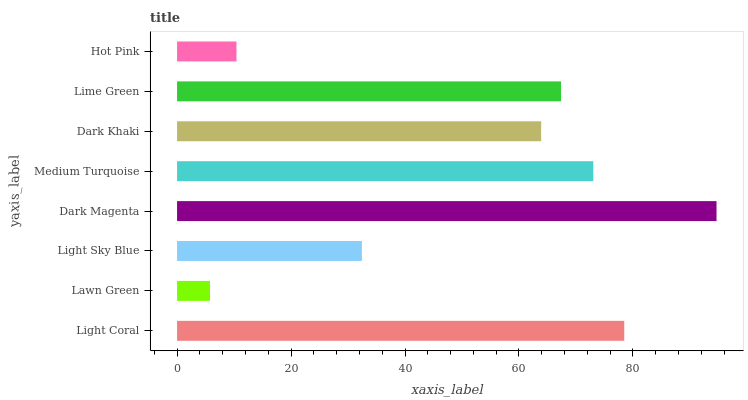Is Lawn Green the minimum?
Answer yes or no. Yes. Is Dark Magenta the maximum?
Answer yes or no. Yes. Is Light Sky Blue the minimum?
Answer yes or no. No. Is Light Sky Blue the maximum?
Answer yes or no. No. Is Light Sky Blue greater than Lawn Green?
Answer yes or no. Yes. Is Lawn Green less than Light Sky Blue?
Answer yes or no. Yes. Is Lawn Green greater than Light Sky Blue?
Answer yes or no. No. Is Light Sky Blue less than Lawn Green?
Answer yes or no. No. Is Lime Green the high median?
Answer yes or no. Yes. Is Dark Khaki the low median?
Answer yes or no. Yes. Is Light Sky Blue the high median?
Answer yes or no. No. Is Lime Green the low median?
Answer yes or no. No. 